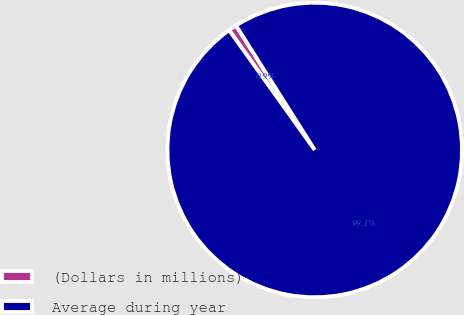Convert chart to OTSL. <chart><loc_0><loc_0><loc_500><loc_500><pie_chart><fcel>(Dollars in millions)<fcel>Average during year<nl><fcel>0.9%<fcel>99.1%<nl></chart> 